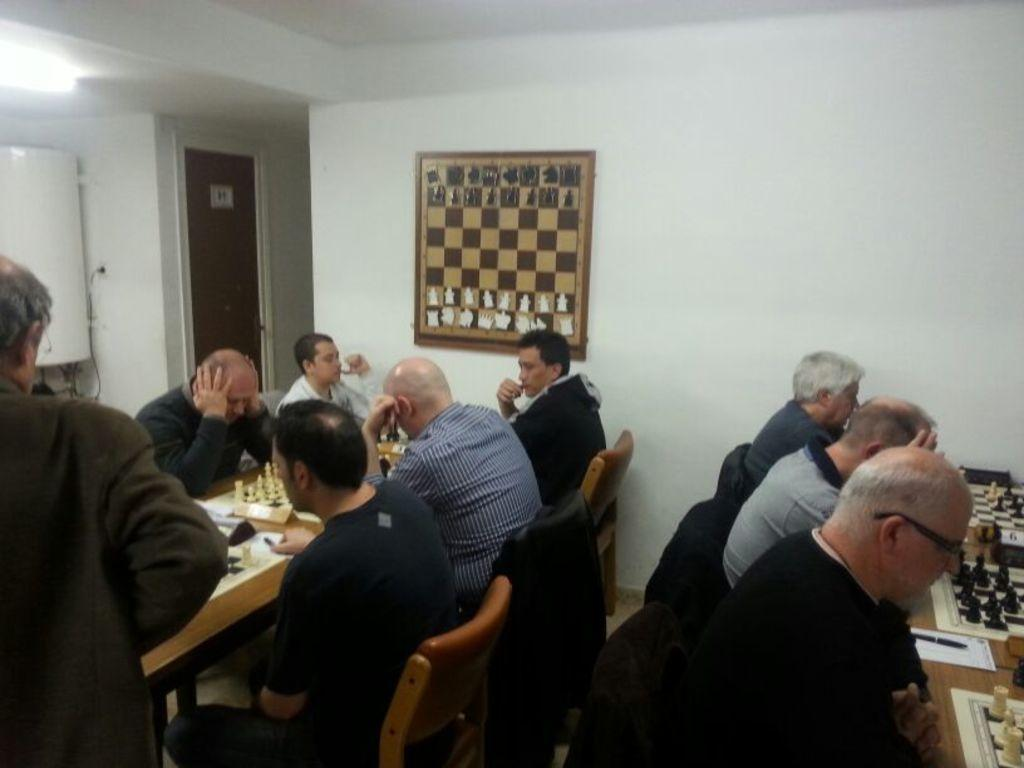What are the people in the image doing? The people are sitting around a table and playing chess. What can be seen on the wall in the image? There is a chess painting on the wall. What type of crown is being worn by the pig in the image? There are no pigs or crowns present in the image. 